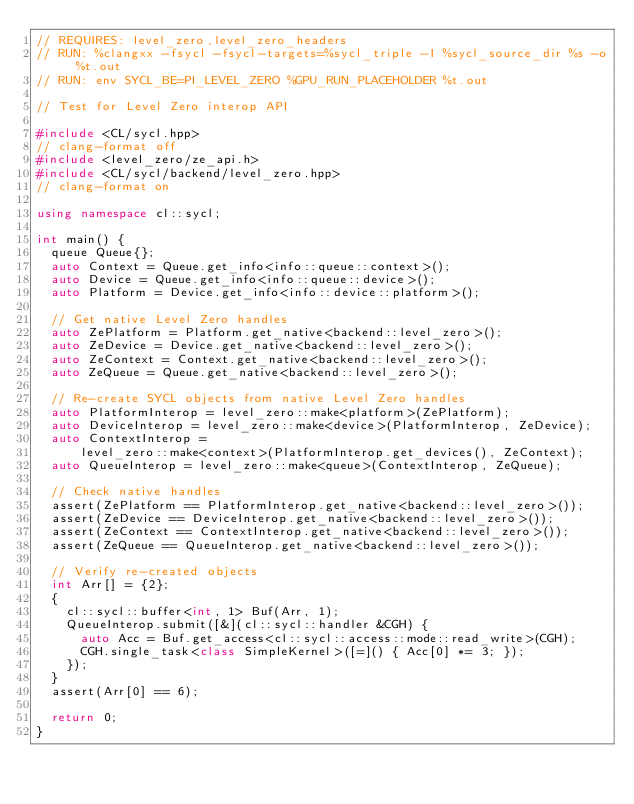Convert code to text. <code><loc_0><loc_0><loc_500><loc_500><_C++_>// REQUIRES: level_zero,level_zero_headers
// RUN: %clangxx -fsycl -fsycl-targets=%sycl_triple -I %sycl_source_dir %s -o %t.out
// RUN: env SYCL_BE=PI_LEVEL_ZERO %GPU_RUN_PLACEHOLDER %t.out

// Test for Level Zero interop API

#include <CL/sycl.hpp>
// clang-format off
#include <level_zero/ze_api.h>
#include <CL/sycl/backend/level_zero.hpp>
// clang-format on

using namespace cl::sycl;

int main() {
  queue Queue{};
  auto Context = Queue.get_info<info::queue::context>();
  auto Device = Queue.get_info<info::queue::device>();
  auto Platform = Device.get_info<info::device::platform>();

  // Get native Level Zero handles
  auto ZePlatform = Platform.get_native<backend::level_zero>();
  auto ZeDevice = Device.get_native<backend::level_zero>();
  auto ZeContext = Context.get_native<backend::level_zero>();
  auto ZeQueue = Queue.get_native<backend::level_zero>();

  // Re-create SYCL objects from native Level Zero handles
  auto PlatformInterop = level_zero::make<platform>(ZePlatform);
  auto DeviceInterop = level_zero::make<device>(PlatformInterop, ZeDevice);
  auto ContextInterop =
      level_zero::make<context>(PlatformInterop.get_devices(), ZeContext);
  auto QueueInterop = level_zero::make<queue>(ContextInterop, ZeQueue);

  // Check native handles
  assert(ZePlatform == PlatformInterop.get_native<backend::level_zero>());
  assert(ZeDevice == DeviceInterop.get_native<backend::level_zero>());
  assert(ZeContext == ContextInterop.get_native<backend::level_zero>());
  assert(ZeQueue == QueueInterop.get_native<backend::level_zero>());

  // Verify re-created objects
  int Arr[] = {2};
  {
    cl::sycl::buffer<int, 1> Buf(Arr, 1);
    QueueInterop.submit([&](cl::sycl::handler &CGH) {
      auto Acc = Buf.get_access<cl::sycl::access::mode::read_write>(CGH);
      CGH.single_task<class SimpleKernel>([=]() { Acc[0] *= 3; });
    });
  }
  assert(Arr[0] == 6);

  return 0;
}
</code> 